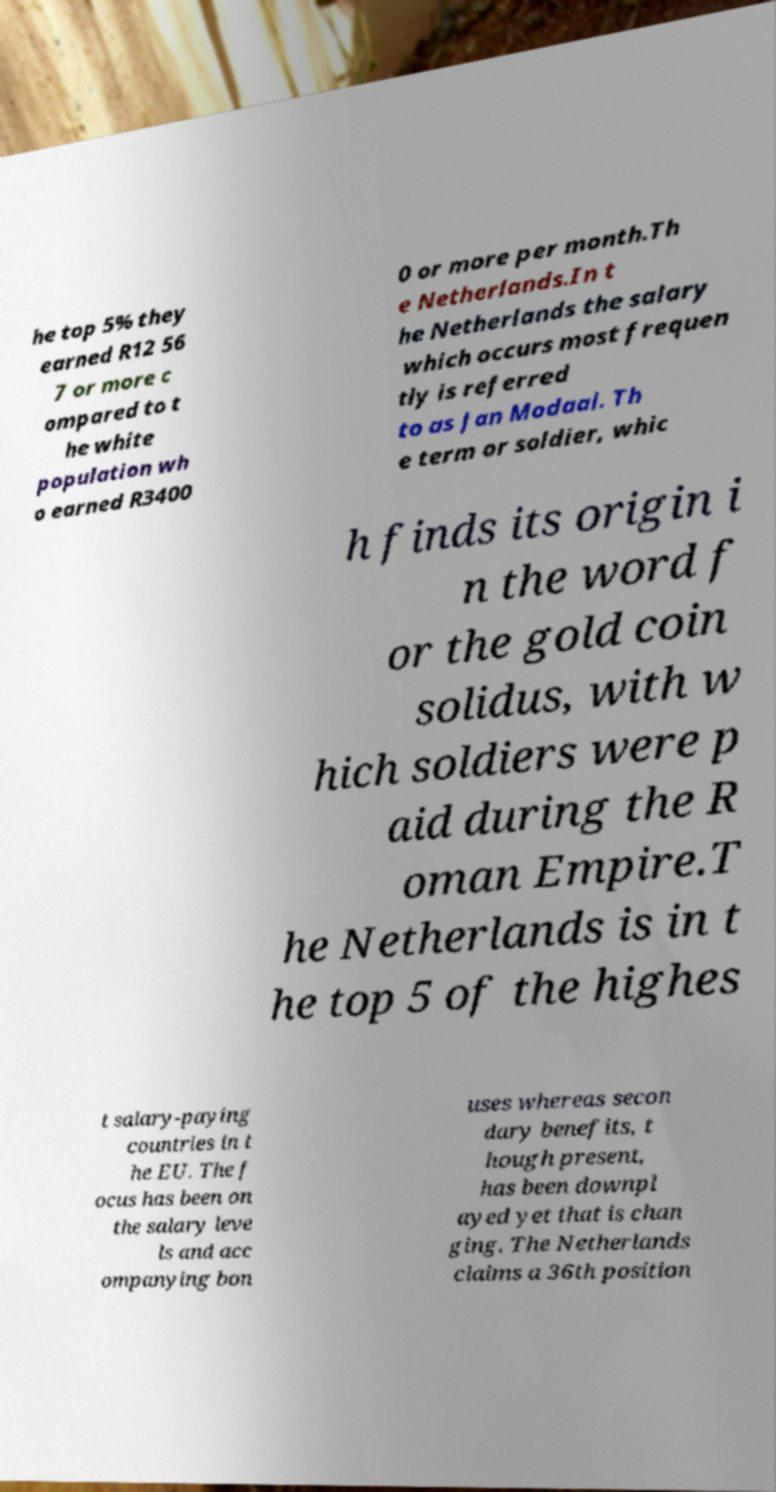Please read and relay the text visible in this image. What does it say? he top 5% they earned R12 56 7 or more c ompared to t he white population wh o earned R3400 0 or more per month.Th e Netherlands.In t he Netherlands the salary which occurs most frequen tly is referred to as Jan Modaal. Th e term or soldier, whic h finds its origin i n the word f or the gold coin solidus, with w hich soldiers were p aid during the R oman Empire.T he Netherlands is in t he top 5 of the highes t salary-paying countries in t he EU. The f ocus has been on the salary leve ls and acc ompanying bon uses whereas secon dary benefits, t hough present, has been downpl ayed yet that is chan ging. The Netherlands claims a 36th position 